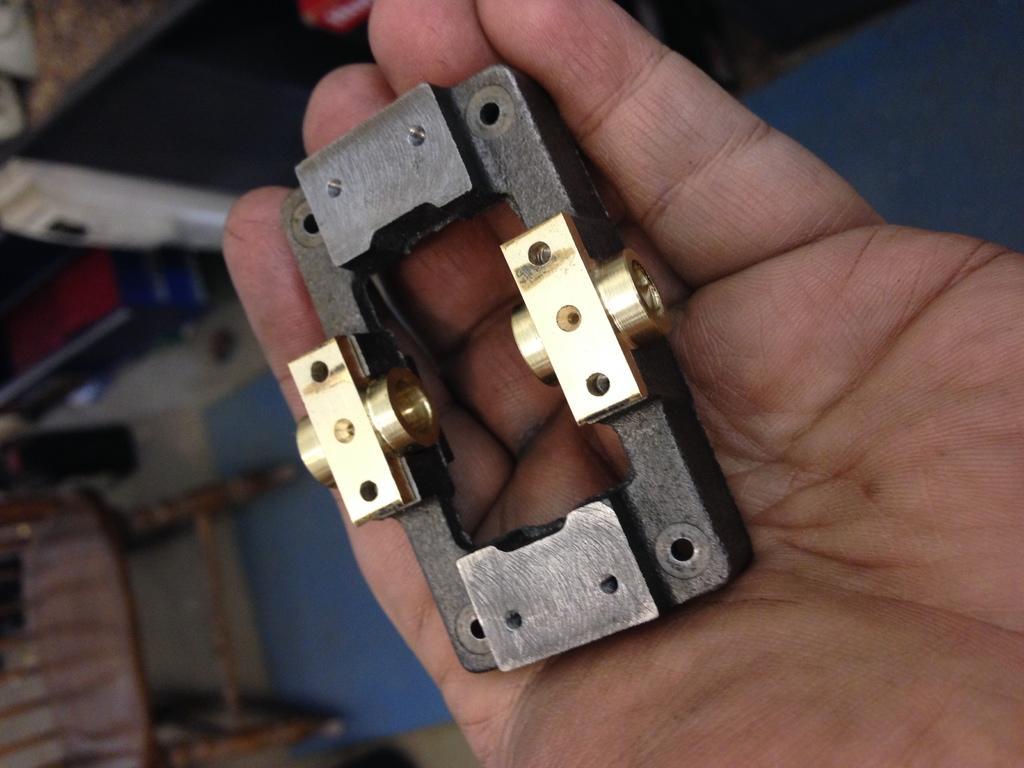Please provide a concise description of this image. In this image we can see an object on hand of a person. In the background, we can see a chair placed on the ground. 